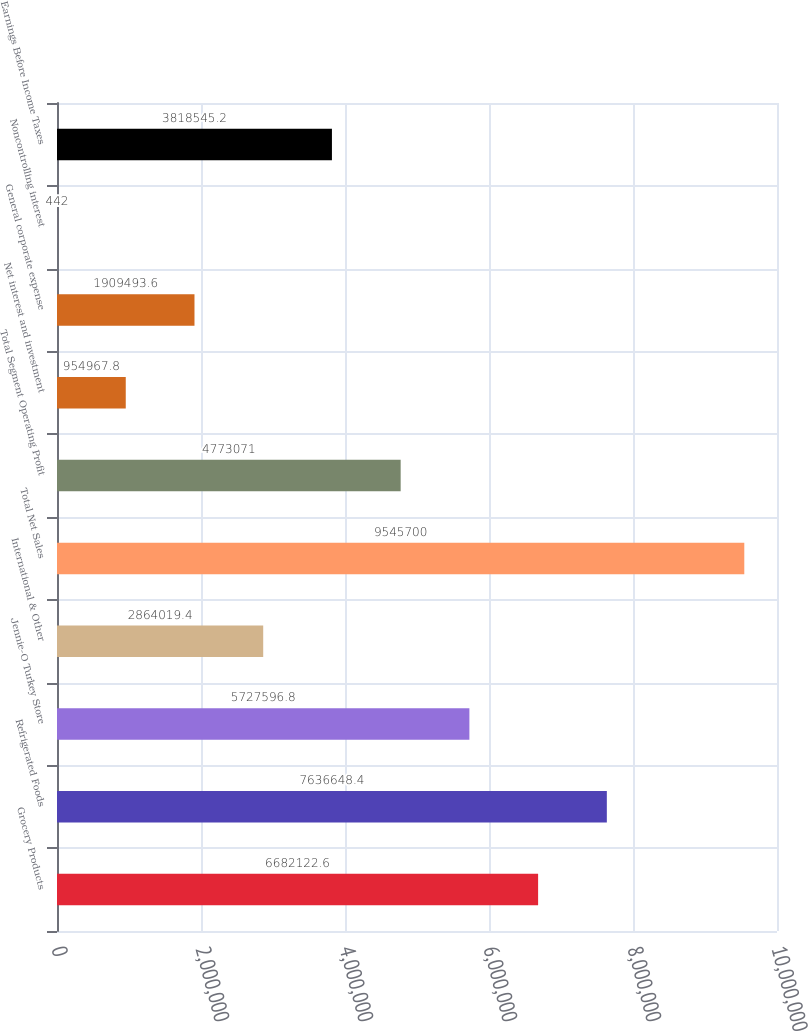<chart> <loc_0><loc_0><loc_500><loc_500><bar_chart><fcel>Grocery Products<fcel>Refrigerated Foods<fcel>Jennie-O Turkey Store<fcel>International & Other<fcel>Total Net Sales<fcel>Total Segment Operating Profit<fcel>Net interest and investment<fcel>General corporate expense<fcel>Noncontrolling interest<fcel>Earnings Before Income Taxes<nl><fcel>6.68212e+06<fcel>7.63665e+06<fcel>5.7276e+06<fcel>2.86402e+06<fcel>9.5457e+06<fcel>4.77307e+06<fcel>954968<fcel>1.90949e+06<fcel>442<fcel>3.81855e+06<nl></chart> 